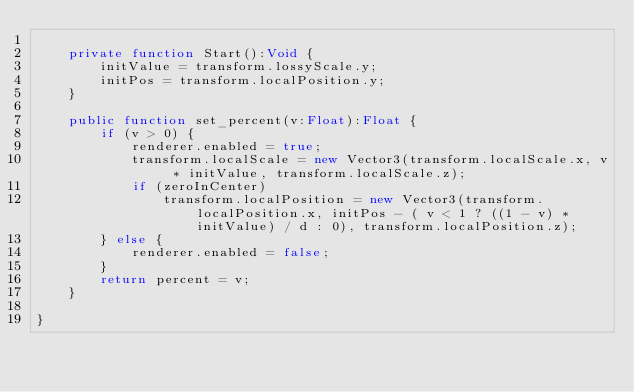Convert code to text. <code><loc_0><loc_0><loc_500><loc_500><_Haxe_>	
	private function Start():Void {
		initValue = transform.lossyScale.y;
		initPos = transform.localPosition.y;
	}
	
	public function set_percent(v:Float):Float {
		if (v > 0) {
			renderer.enabled = true;
			transform.localScale = new Vector3(transform.localScale.x, v * initValue, transform.localScale.z);
			if (zeroInCenter)
				transform.localPosition = new Vector3(transform.localPosition.x, initPos - ( v < 1 ? ((1 - v) * initValue) / d : 0), transform.localPosition.z);
		} else {
			renderer.enabled = false;
		}
		return percent = v;
	}
	
}</code> 